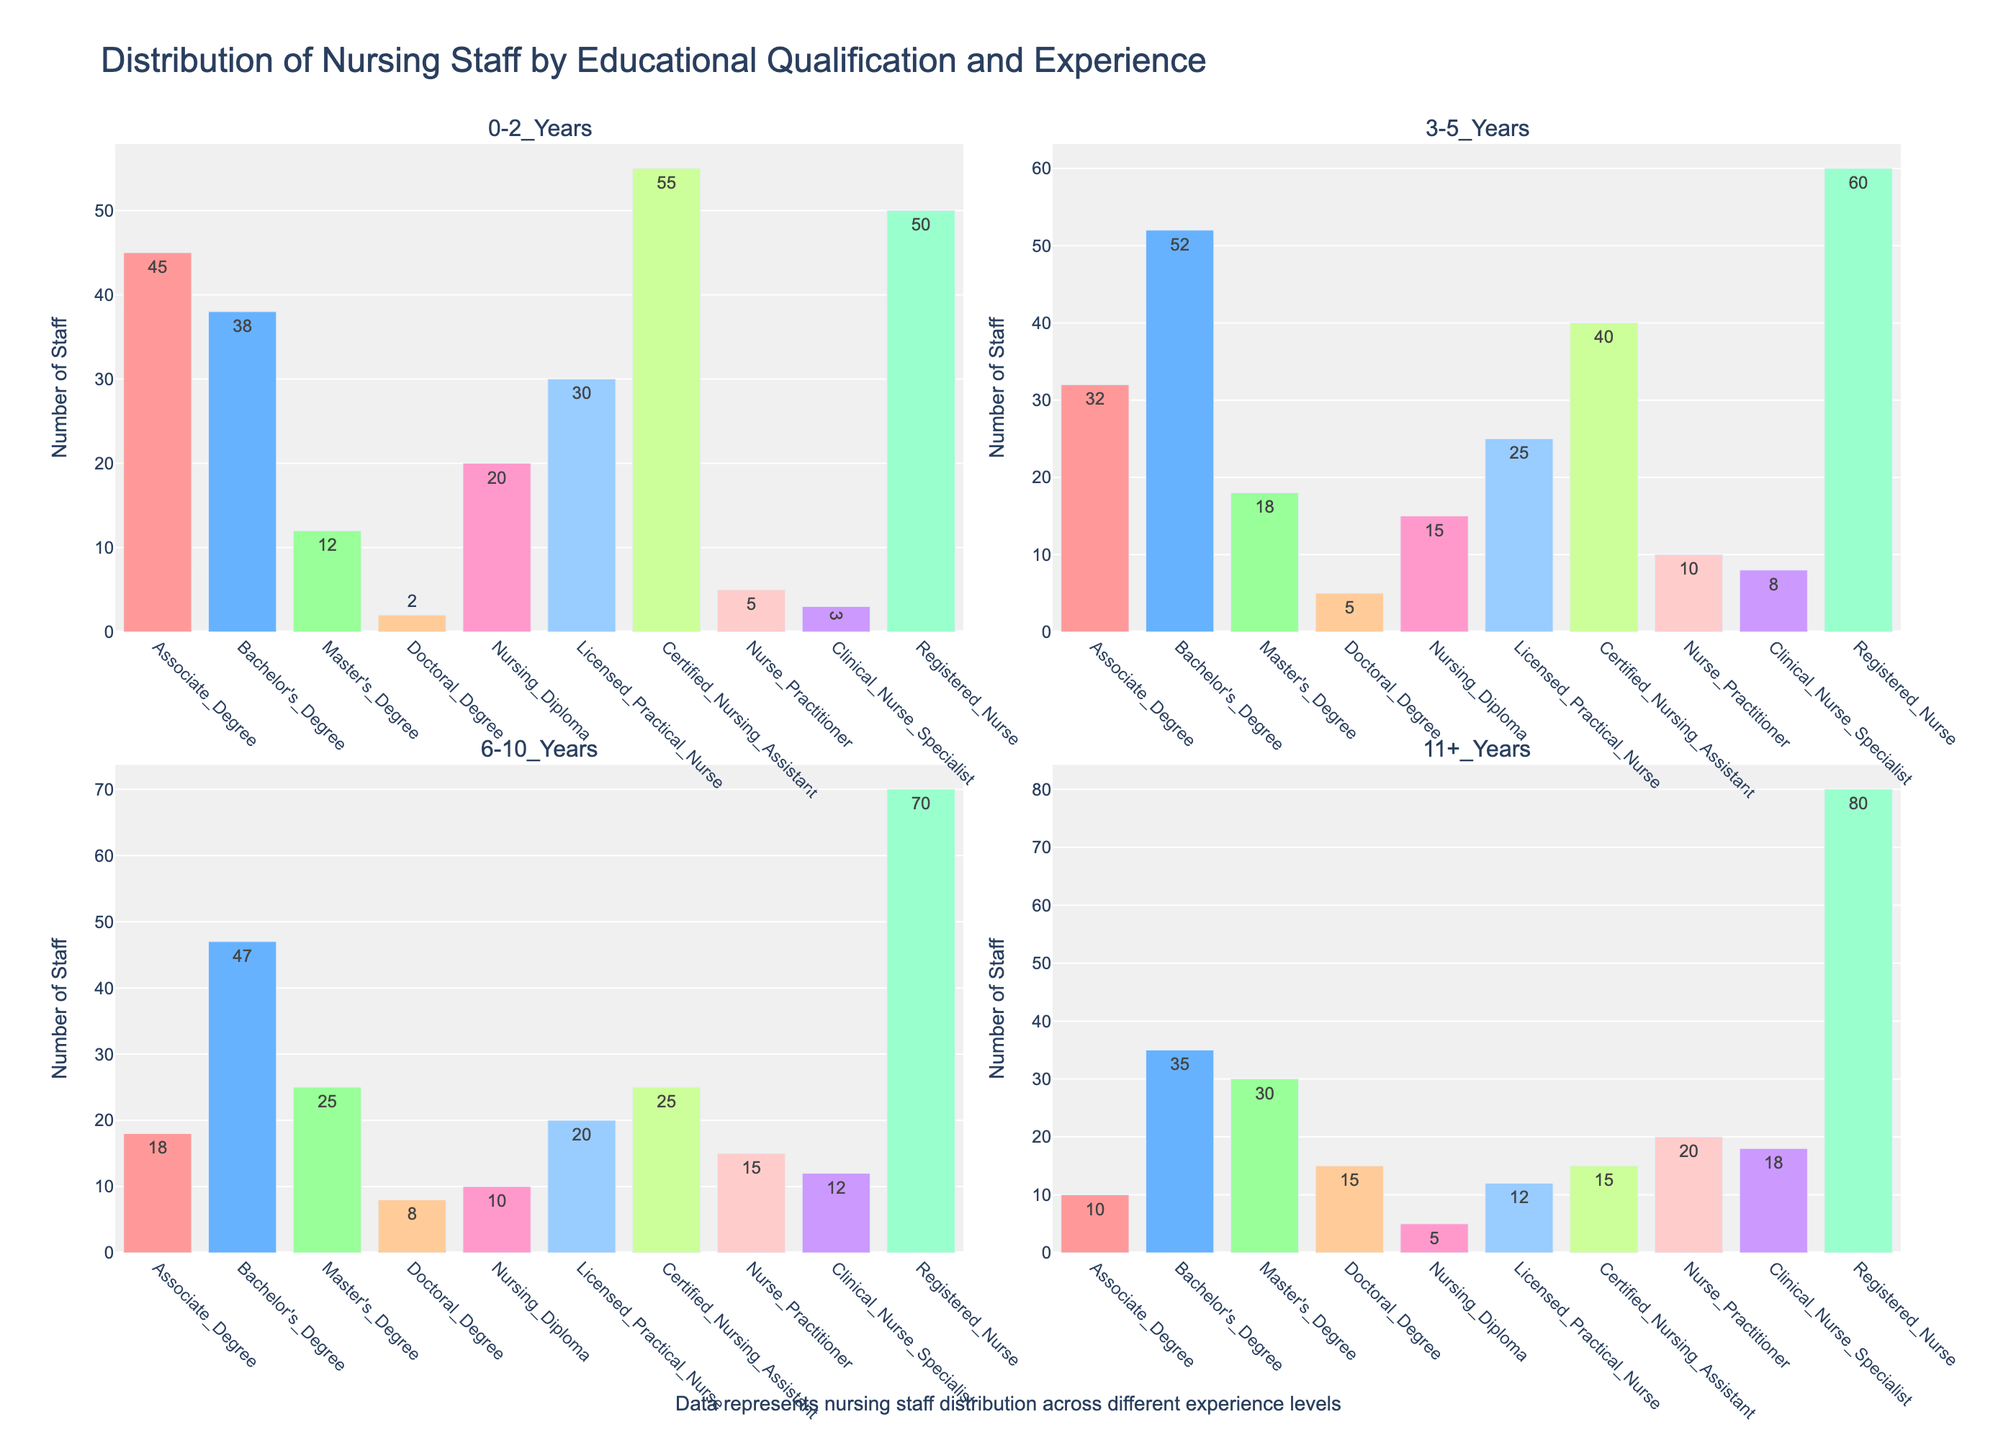What's the total number of nursing staff with a Bachelor's Degree across all experience levels? Sum the values associated with "Bachelor's_Degree" across all experience ranges: 38 (0-2 Years) + 52 (3-5 Years) + 47 (6-10 Years) + 35 (11+ Years) = 172
Answer: 172 Which educational qualification has the largest number of staff with 0-2 years of experience? Compare the heights of the bars for the 0-2 years category only. The tallest bar corresponds to "Certified_Nursing_Assistant" with 55 staff members.
Answer: Certified_Nursing_Assistant How many more Registered Nurses have 11+ years of experience compared to those with Associate Degrees in the same experience range? Subtract the number of staff with Associate Degrees in the 11+ years category from the number of Registered Nurses: 80 (Registered_Nurse in 11+ Years) - 10 (Associate_Degree in 11+ Years) = 70
Answer: 70 What is the average number of staff with a Master's Degree across all experience levels? Sum the values for "Master's_Degree" across all experience ranges and divide by 4 (number of experience categories): (12 + 18 + 25 + 30) / 4 = 21.25
Answer: 21.25 Which experience range has the fewest number of Doctoral Degree holders? Compare the heights of the bars for Doctoral Degree holders across all experience categories. The shortest bar corresponds to the 0-2 years range, with only 2 staff members.
Answer: 0-2 Years How does the number of Licensed Practical Nurses with 3-5 years of experience compare to those with 6-10 years? Compare the bar heights for Licensed Practical Nurses in the 3-5 years and 6-10 years categories. 25 (3-5 Years) is greater than 20 (6-10 Years).
Answer: 3-5 Years has more What's the difference in the number of staff with an Associate Degree and those with a Nursing Diploma in the 6-10 years experience range? Subtract the number of staff with a Nursing Diploma in the 6-10 years range from those with an Associate Degree: 18 (Associate_Degree in 6-10 Years) - 10 (Nursing_Diploma in 6-10 Years) = 8
Answer: 8 How many total staff members have 11+ years of experience? Sum the values across all educational qualifications for the 11+ years category: 10 (Associate Degree) + 35 (Bachelor's Degree) + 30 (Master's Degree) + 15 (Doctoral Degree) + 5 (Nursing Diploma) + 12 (Licensed Practical Nurse) + 15 (Certified Nursing Assistant) + 20 (Nurse Practitioner) + 18 (Clinical Nurse Specialist) + 80 (Registered Nurse) = 240
Answer: 240 